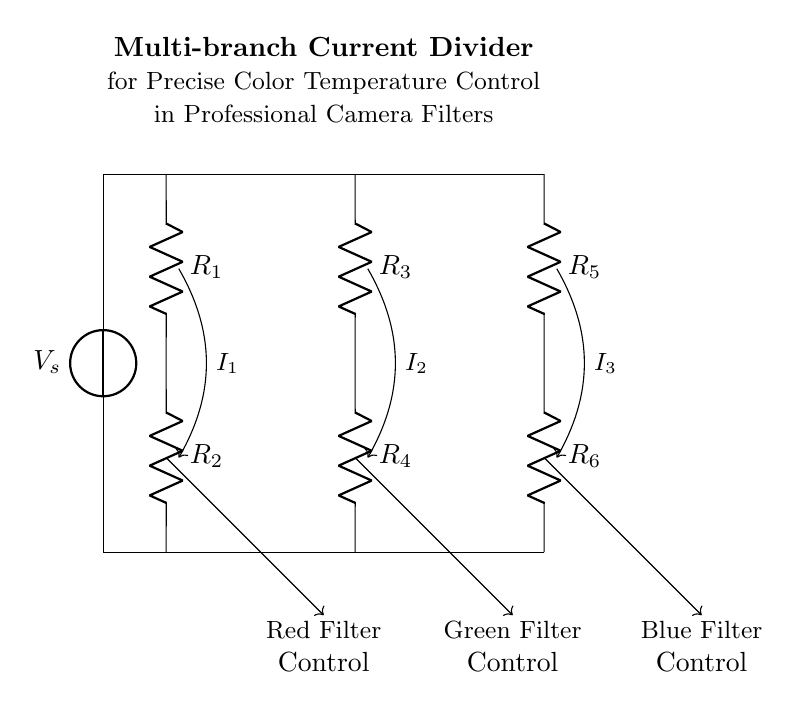What is the total number of resistors in the circuit? There are six resistors labeled R1, R2, R3, R4, R5, and R6, each positioned in three parallel branches. Counting them gives a total of six resistors.
Answer: Six What is the purpose of the current divider in this circuit? The current divider allows the division of the input current into multiple output currents that can be used for controlling the intensity of different color filters, allowing for proper color temperature adjustments in professional cameras.
Answer: Color temperature control What kind of current does each branch carry? Each branch carries a different output current denoted as I1, I2, and I3, which are responsible for controlling the red, green, and blue filters, respectively.
Answer: Red, green, blue Which resistors are in the same branch? R1 and R2 are in the first branch, R3 and R4 are in the second branch, and R5 and R6 are in the third branch, indicating that they are paired within their respective paths.
Answer: R1 and R2; R3 and R4; R5 and R6 What is the output current for the red filter represented by? The output current for the red filter is represented by I1, which flows from the junction between R1 and R2 to the filter control. This is depicted by the arrow labeled I1.
Answer: I1 How does the circuit achieve precise control over color temperature? The circuit achieves precise control by allowing different currents to flow through the individual branches, each corresponding to a specific color filter, thus allowing fine-tuning of the color output based on the resistance values set in the branches.
Answer: By varying branch resistances 